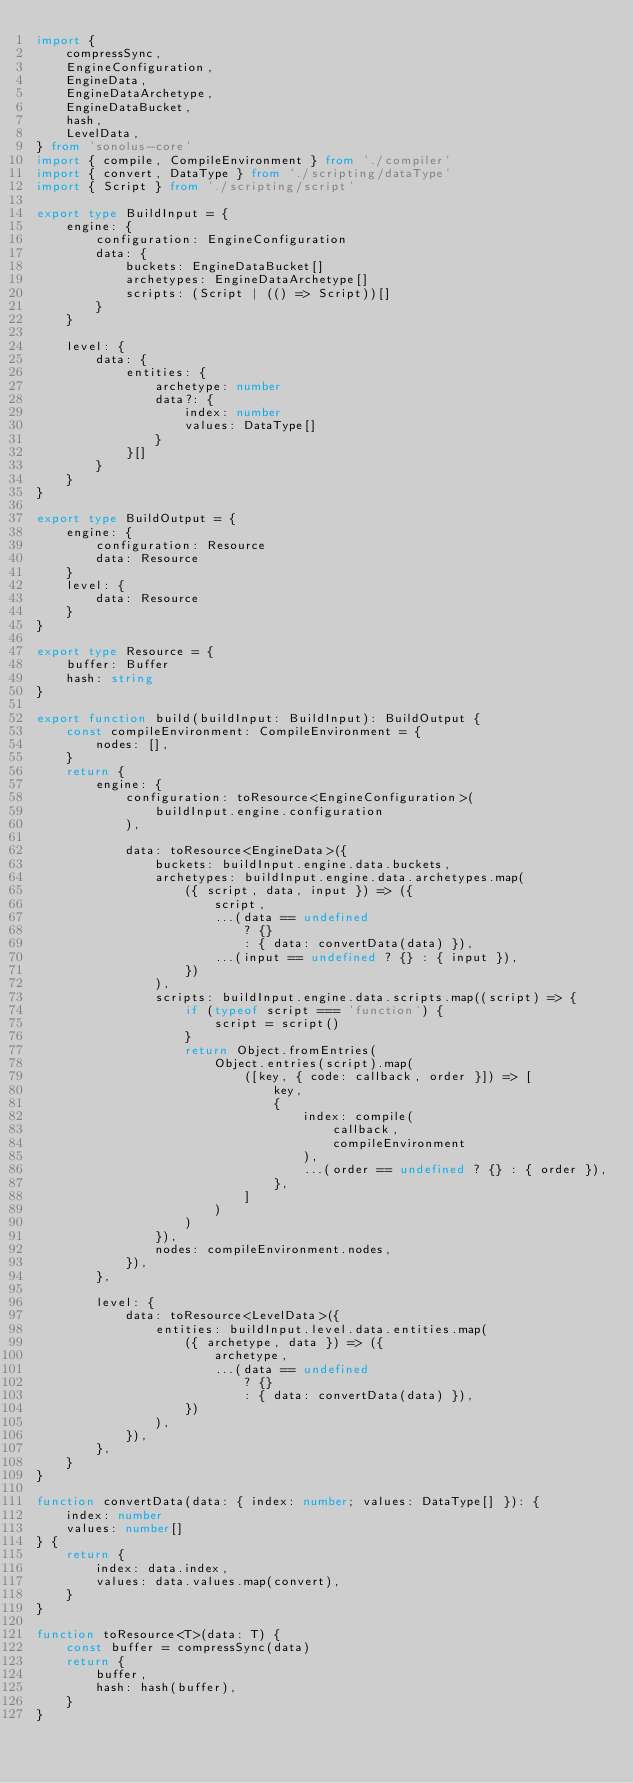Convert code to text. <code><loc_0><loc_0><loc_500><loc_500><_TypeScript_>import {
    compressSync,
    EngineConfiguration,
    EngineData,
    EngineDataArchetype,
    EngineDataBucket,
    hash,
    LevelData,
} from 'sonolus-core'
import { compile, CompileEnvironment } from './compiler'
import { convert, DataType } from './scripting/dataType'
import { Script } from './scripting/script'

export type BuildInput = {
    engine: {
        configuration: EngineConfiguration
        data: {
            buckets: EngineDataBucket[]
            archetypes: EngineDataArchetype[]
            scripts: (Script | (() => Script))[]
        }
    }

    level: {
        data: {
            entities: {
                archetype: number
                data?: {
                    index: number
                    values: DataType[]
                }
            }[]
        }
    }
}

export type BuildOutput = {
    engine: {
        configuration: Resource
        data: Resource
    }
    level: {
        data: Resource
    }
}

export type Resource = {
    buffer: Buffer
    hash: string
}

export function build(buildInput: BuildInput): BuildOutput {
    const compileEnvironment: CompileEnvironment = {
        nodes: [],
    }
    return {
        engine: {
            configuration: toResource<EngineConfiguration>(
                buildInput.engine.configuration
            ),

            data: toResource<EngineData>({
                buckets: buildInput.engine.data.buckets,
                archetypes: buildInput.engine.data.archetypes.map(
                    ({ script, data, input }) => ({
                        script,
                        ...(data == undefined
                            ? {}
                            : { data: convertData(data) }),
                        ...(input == undefined ? {} : { input }),
                    })
                ),
                scripts: buildInput.engine.data.scripts.map((script) => {
                    if (typeof script === 'function') {
                        script = script()
                    }
                    return Object.fromEntries(
                        Object.entries(script).map(
                            ([key, { code: callback, order }]) => [
                                key,
                                {
                                    index: compile(
                                        callback,
                                        compileEnvironment
                                    ),
                                    ...(order == undefined ? {} : { order }),
                                },
                            ]
                        )
                    )
                }),
                nodes: compileEnvironment.nodes,
            }),
        },

        level: {
            data: toResource<LevelData>({
                entities: buildInput.level.data.entities.map(
                    ({ archetype, data }) => ({
                        archetype,
                        ...(data == undefined
                            ? {}
                            : { data: convertData(data) }),
                    })
                ),
            }),
        },
    }
}

function convertData(data: { index: number; values: DataType[] }): {
    index: number
    values: number[]
} {
    return {
        index: data.index,
        values: data.values.map(convert),
    }
}

function toResource<T>(data: T) {
    const buffer = compressSync(data)
    return {
        buffer,
        hash: hash(buffer),
    }
}
</code> 